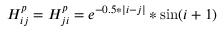<formula> <loc_0><loc_0><loc_500><loc_500>H _ { i j } ^ { p } = H _ { j i } ^ { p } = e ^ { - 0 . 5 * | i - j | } * \sin ( i + 1 )</formula> 